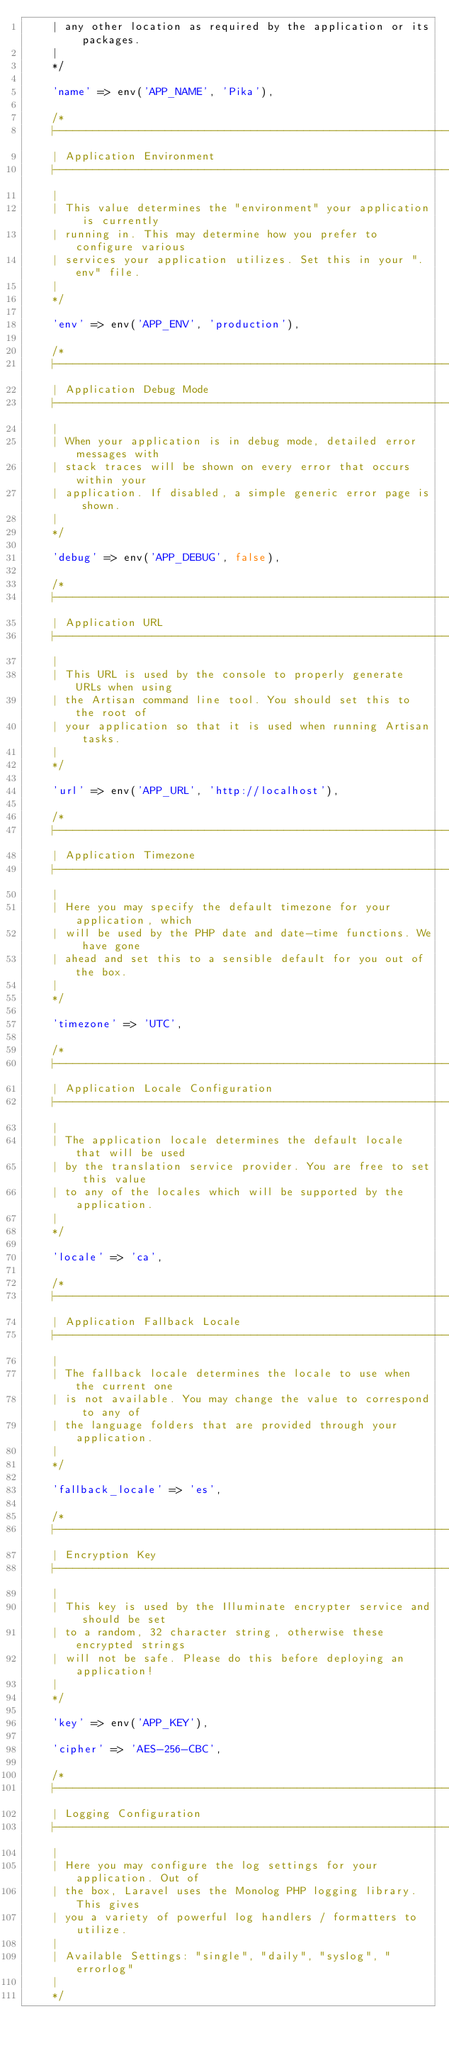Convert code to text. <code><loc_0><loc_0><loc_500><loc_500><_PHP_>    | any other location as required by the application or its packages.
    |
    */

    'name' => env('APP_NAME', 'Pika'),

    /*
    |--------------------------------------------------------------------------
    | Application Environment
    |--------------------------------------------------------------------------
    |
    | This value determines the "environment" your application is currently
    | running in. This may determine how you prefer to configure various
    | services your application utilizes. Set this in your ".env" file.
    |
    */

    'env' => env('APP_ENV', 'production'),

    /*
    |--------------------------------------------------------------------------
    | Application Debug Mode
    |--------------------------------------------------------------------------
    |
    | When your application is in debug mode, detailed error messages with
    | stack traces will be shown on every error that occurs within your
    | application. If disabled, a simple generic error page is shown.
    |
    */

    'debug' => env('APP_DEBUG', false),

    /*
    |--------------------------------------------------------------------------
    | Application URL
    |--------------------------------------------------------------------------
    |
    | This URL is used by the console to properly generate URLs when using
    | the Artisan command line tool. You should set this to the root of
    | your application so that it is used when running Artisan tasks.
    |
    */

    'url' => env('APP_URL', 'http://localhost'),

    /*
    |--------------------------------------------------------------------------
    | Application Timezone
    |--------------------------------------------------------------------------
    |
    | Here you may specify the default timezone for your application, which
    | will be used by the PHP date and date-time functions. We have gone
    | ahead and set this to a sensible default for you out of the box.
    |
    */

    'timezone' => 'UTC',

    /*
    |--------------------------------------------------------------------------
    | Application Locale Configuration
    |--------------------------------------------------------------------------
    |
    | The application locale determines the default locale that will be used
    | by the translation service provider. You are free to set this value
    | to any of the locales which will be supported by the application.
    |
    */

    'locale' => 'ca',

    /*
    |--------------------------------------------------------------------------
    | Application Fallback Locale
    |--------------------------------------------------------------------------
    |
    | The fallback locale determines the locale to use when the current one
    | is not available. You may change the value to correspond to any of
    | the language folders that are provided through your application.
    |
    */

    'fallback_locale' => 'es',

    /*
    |--------------------------------------------------------------------------
    | Encryption Key
    |--------------------------------------------------------------------------
    |
    | This key is used by the Illuminate encrypter service and should be set
    | to a random, 32 character string, otherwise these encrypted strings
    | will not be safe. Please do this before deploying an application!
    |
    */

    'key' => env('APP_KEY'),

    'cipher' => 'AES-256-CBC',

    /*
    |--------------------------------------------------------------------------
    | Logging Configuration
    |--------------------------------------------------------------------------
    |
    | Here you may configure the log settings for your application. Out of
    | the box, Laravel uses the Monolog PHP logging library. This gives
    | you a variety of powerful log handlers / formatters to utilize.
    |
    | Available Settings: "single", "daily", "syslog", "errorlog"
    |
    */
</code> 